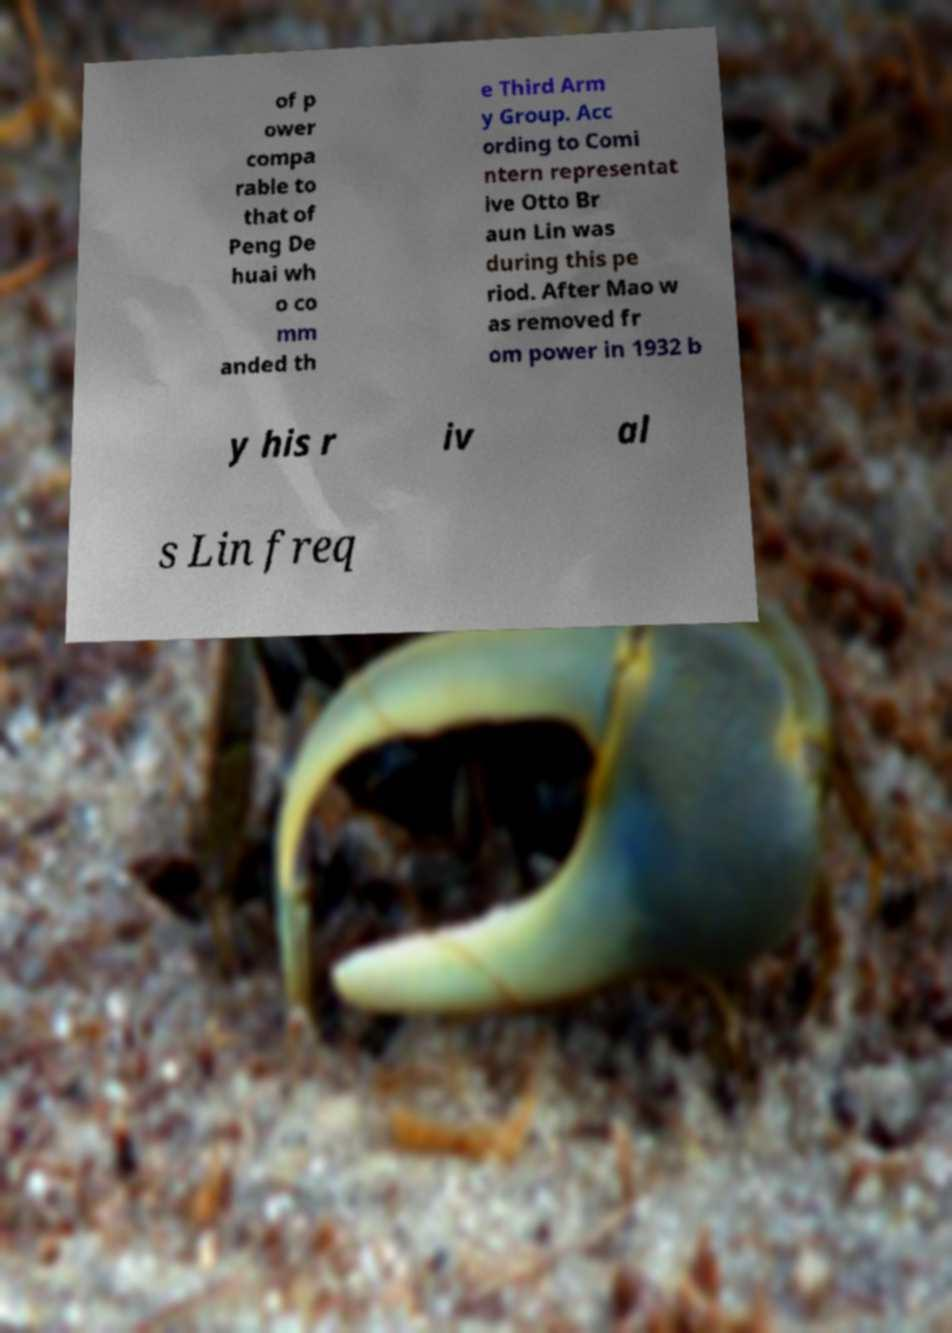There's text embedded in this image that I need extracted. Can you transcribe it verbatim? of p ower compa rable to that of Peng De huai wh o co mm anded th e Third Arm y Group. Acc ording to Comi ntern representat ive Otto Br aun Lin was during this pe riod. After Mao w as removed fr om power in 1932 b y his r iv al s Lin freq 